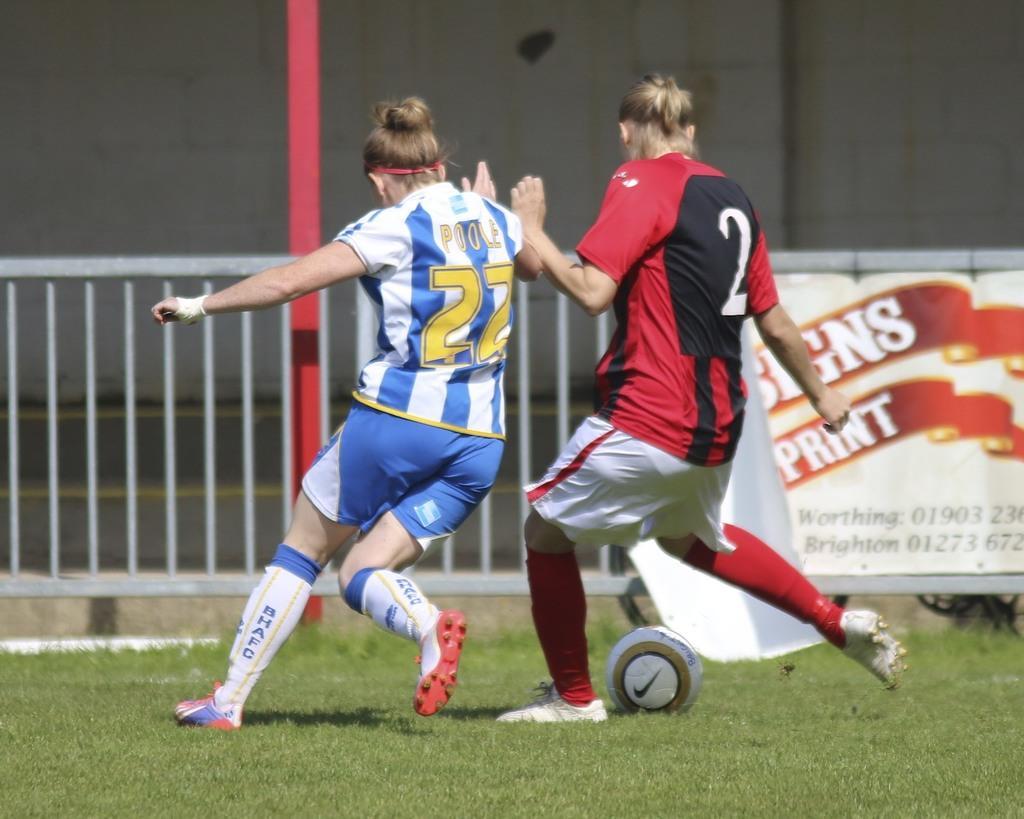Could you give a brief overview of what you see in this image? There are two people. They are playing a game. On the right side person kicking a ball. They both wear colorful shirts. We can see the background nice ground ,wall and banner. 